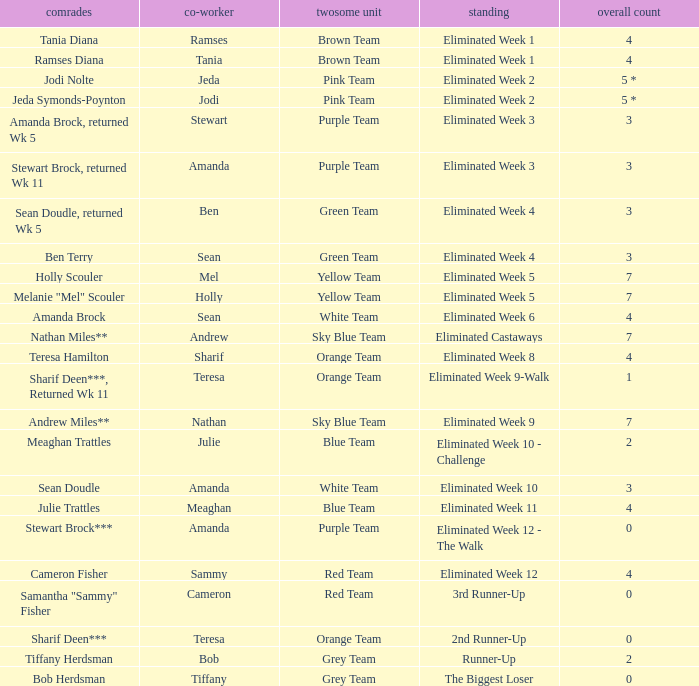What was Holly Scouler's total votes 7.0. 